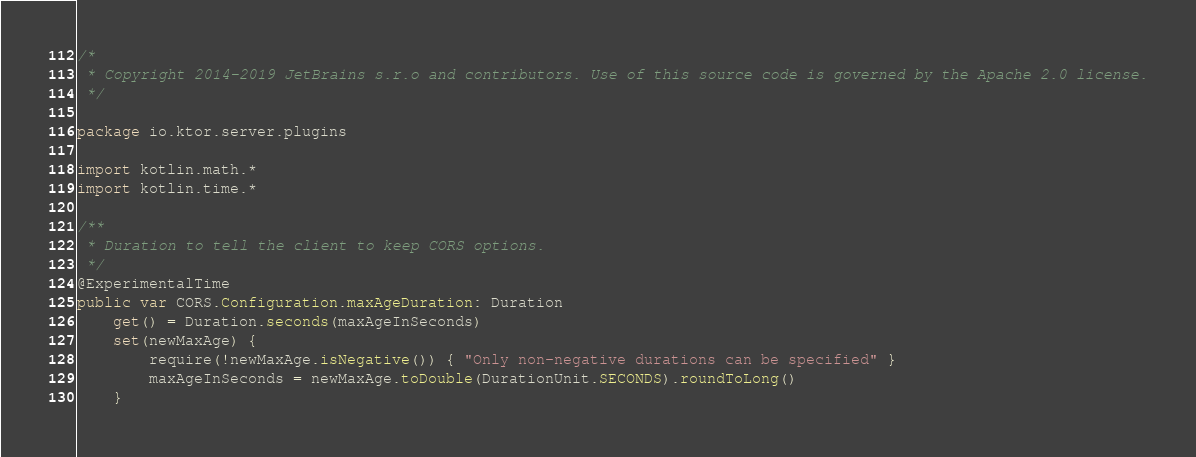<code> <loc_0><loc_0><loc_500><loc_500><_Kotlin_>/*
 * Copyright 2014-2019 JetBrains s.r.o and contributors. Use of this source code is governed by the Apache 2.0 license.
 */

package io.ktor.server.plugins

import kotlin.math.*
import kotlin.time.*

/**
 * Duration to tell the client to keep CORS options.
 */
@ExperimentalTime
public var CORS.Configuration.maxAgeDuration: Duration
    get() = Duration.seconds(maxAgeInSeconds)
    set(newMaxAge) {
        require(!newMaxAge.isNegative()) { "Only non-negative durations can be specified" }
        maxAgeInSeconds = newMaxAge.toDouble(DurationUnit.SECONDS).roundToLong()
    }
</code> 